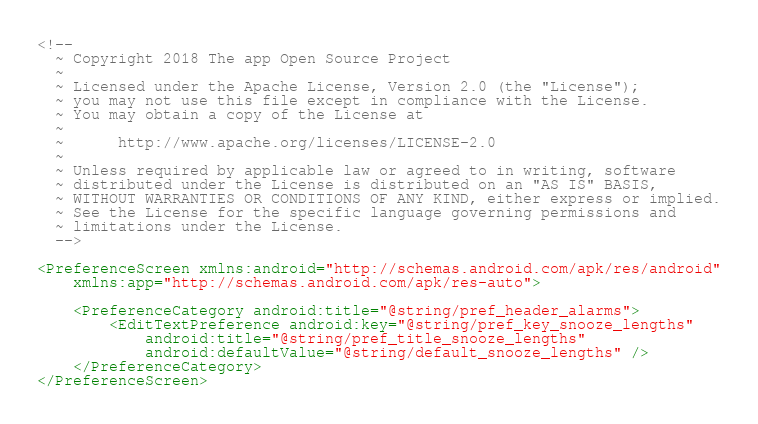Convert code to text. <code><loc_0><loc_0><loc_500><loc_500><_XML_><!--
  ~ Copyright 2018 The app Open Source Project
  ~
  ~ Licensed under the Apache License, Version 2.0 (the "License");
  ~ you may not use this file except in compliance with the License.
  ~ You may obtain a copy of the License at
  ~
  ~      http://www.apache.org/licenses/LICENSE-2.0
  ~
  ~ Unless required by applicable law or agreed to in writing, software
  ~ distributed under the License is distributed on an "AS IS" BASIS,
  ~ WITHOUT WARRANTIES OR CONDITIONS OF ANY KIND, either express or implied.
  ~ See the License for the specific language governing permissions and
  ~ limitations under the License.
  -->

<PreferenceScreen xmlns:android="http://schemas.android.com/apk/res/android"
    xmlns:app="http://schemas.android.com/apk/res-auto">

    <PreferenceCategory android:title="@string/pref_header_alarms">
        <EditTextPreference android:key="@string/pref_key_snooze_lengths"
            android:title="@string/pref_title_snooze_lengths"
            android:defaultValue="@string/default_snooze_lengths" />
    </PreferenceCategory>
</PreferenceScreen>
</code> 